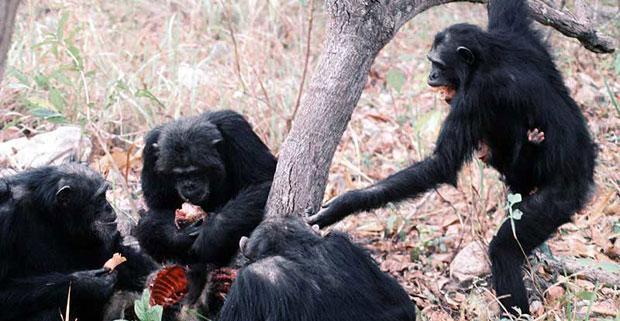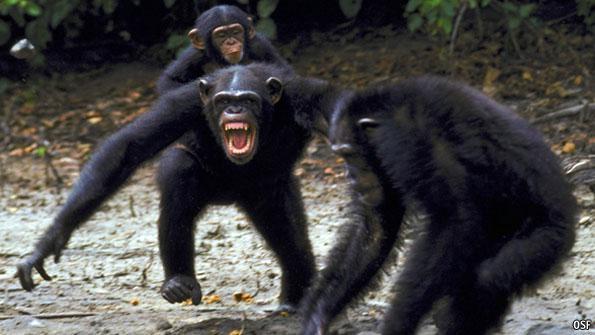The first image is the image on the left, the second image is the image on the right. Given the left and right images, does the statement "An image shows at least three chimps huddled around a piece of carcass." hold true? Answer yes or no. Yes. The first image is the image on the left, the second image is the image on the right. Given the left and right images, does the statement "A group of monkeys is eating meat in one of the images." hold true? Answer yes or no. Yes. 